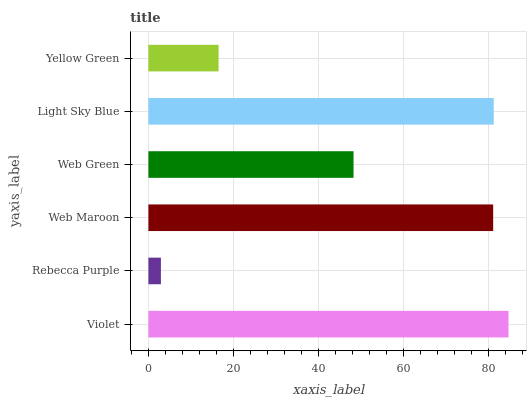Is Rebecca Purple the minimum?
Answer yes or no. Yes. Is Violet the maximum?
Answer yes or no. Yes. Is Web Maroon the minimum?
Answer yes or no. No. Is Web Maroon the maximum?
Answer yes or no. No. Is Web Maroon greater than Rebecca Purple?
Answer yes or no. Yes. Is Rebecca Purple less than Web Maroon?
Answer yes or no. Yes. Is Rebecca Purple greater than Web Maroon?
Answer yes or no. No. Is Web Maroon less than Rebecca Purple?
Answer yes or no. No. Is Web Maroon the high median?
Answer yes or no. Yes. Is Web Green the low median?
Answer yes or no. Yes. Is Violet the high median?
Answer yes or no. No. Is Rebecca Purple the low median?
Answer yes or no. No. 